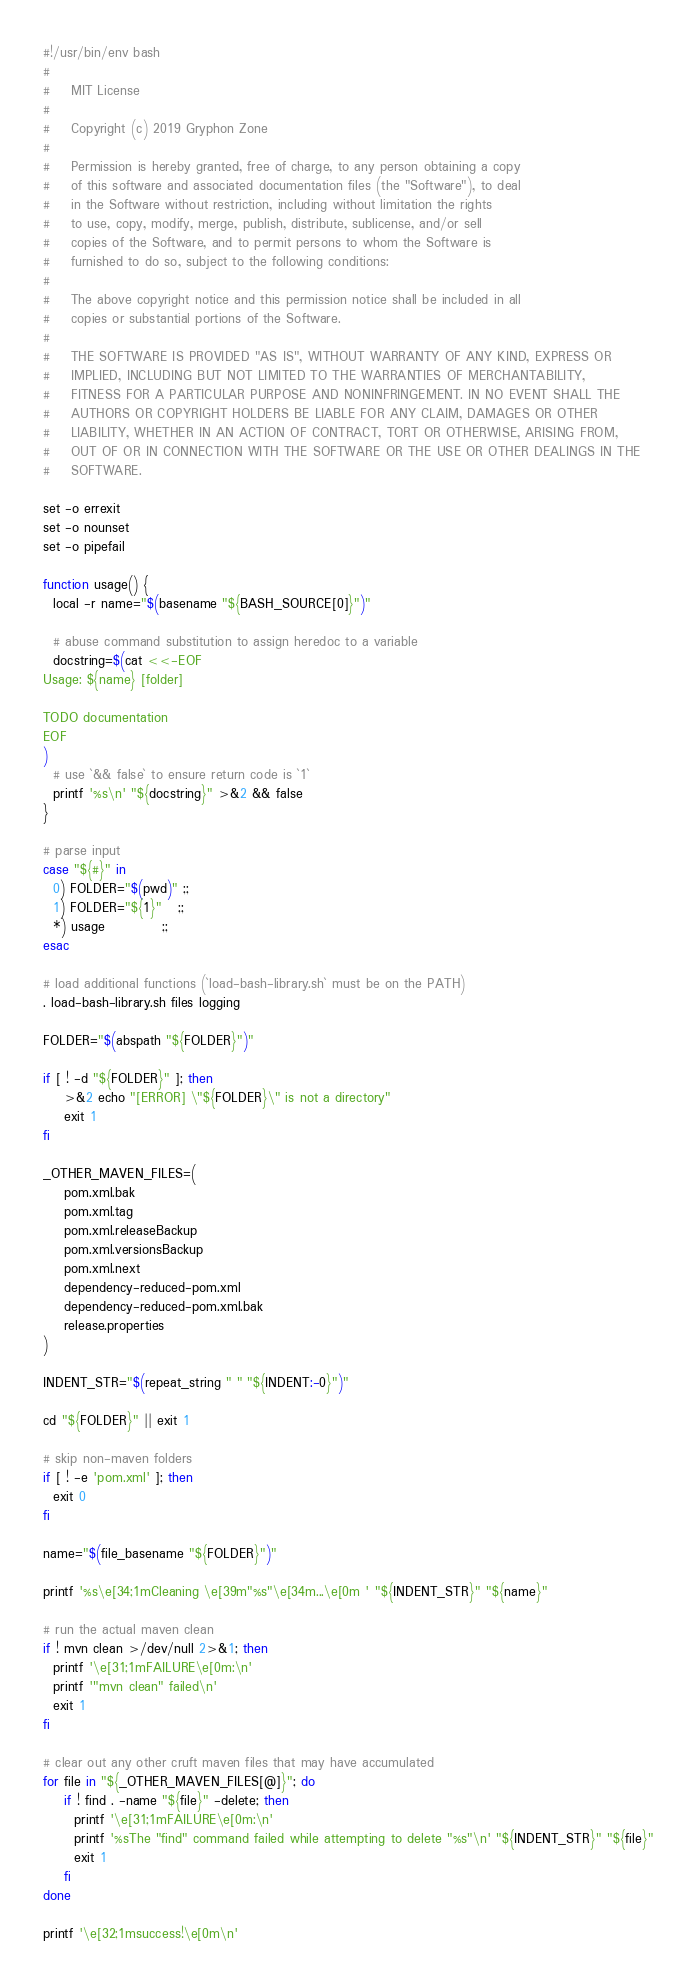Convert code to text. <code><loc_0><loc_0><loc_500><loc_500><_Bash_>#!/usr/bin/env bash
#
#    MIT License
#
#    Copyright (c) 2019 Gryphon Zone
#
#    Permission is hereby granted, free of charge, to any person obtaining a copy
#    of this software and associated documentation files (the "Software"), to deal
#    in the Software without restriction, including without limitation the rights
#    to use, copy, modify, merge, publish, distribute, sublicense, and/or sell
#    copies of the Software, and to permit persons to whom the Software is
#    furnished to do so, subject to the following conditions:
#
#    The above copyright notice and this permission notice shall be included in all
#    copies or substantial portions of the Software.
#
#    THE SOFTWARE IS PROVIDED "AS IS", WITHOUT WARRANTY OF ANY KIND, EXPRESS OR
#    IMPLIED, INCLUDING BUT NOT LIMITED TO THE WARRANTIES OF MERCHANTABILITY,
#    FITNESS FOR A PARTICULAR PURPOSE AND NONINFRINGEMENT. IN NO EVENT SHALL THE
#    AUTHORS OR COPYRIGHT HOLDERS BE LIABLE FOR ANY CLAIM, DAMAGES OR OTHER
#    LIABILITY, WHETHER IN AN ACTION OF CONTRACT, TORT OR OTHERWISE, ARISING FROM,
#    OUT OF OR IN CONNECTION WITH THE SOFTWARE OR THE USE OR OTHER DEALINGS IN THE
#    SOFTWARE.

set -o errexit
set -o nounset
set -o pipefail

function usage() {
  local -r name="$(basename "${BASH_SOURCE[0]}")"

  # abuse command substitution to assign heredoc to a variable
  docstring=$(cat <<-EOF
Usage: ${name} [folder]

TODO documentation
EOF
)
  # use `&& false` to ensure return code is `1`
  printf '%s\n' "${docstring}" >&2 && false
}

# parse input
case "${#}" in
  0) FOLDER="$(pwd)" ;;
  1) FOLDER="${1}"   ;;
  *) usage           ;;
esac

# load additional functions (`load-bash-library.sh` must be on the PATH)
. load-bash-library.sh files logging

FOLDER="$(abspath "${FOLDER}")"

if [ ! -d "${FOLDER}" ]; then
    >&2 echo "[ERROR] \"${FOLDER}\" is not a directory"
    exit 1
fi

_OTHER_MAVEN_FILES=(
    pom.xml.bak
    pom.xml.tag
    pom.xml.releaseBackup
    pom.xml.versionsBackup
    pom.xml.next
    dependency-reduced-pom.xml
    dependency-reduced-pom.xml.bak
    release.properties
)

INDENT_STR="$(repeat_string " " "${INDENT:-0}")"

cd "${FOLDER}" || exit 1

# skip non-maven folders
if [ ! -e 'pom.xml' ]; then
  exit 0
fi

name="$(file_basename "${FOLDER}")"

printf '%s\e[34;1mCleaning \e[39m"%s"\e[34m...\e[0m ' "${INDENT_STR}" "${name}"

# run the actual maven clean
if ! mvn clean >/dev/null 2>&1; then
  printf '\e[31;1mFAILURE\e[0m:\n'
  printf '"mvn clean" failed\n'
  exit 1
fi

# clear out any other cruft maven files that may have accumulated
for file in "${_OTHER_MAVEN_FILES[@]}"; do
    if ! find . -name "${file}" -delete; then
      printf '\e[31;1mFAILURE\e[0m:\n'
      printf '%sThe "find" command failed while attempting to delete "%s"\n' "${INDENT_STR}" "${file}"
      exit 1
    fi
done

printf '\e[32;1msuccess!\e[0m\n'
</code> 